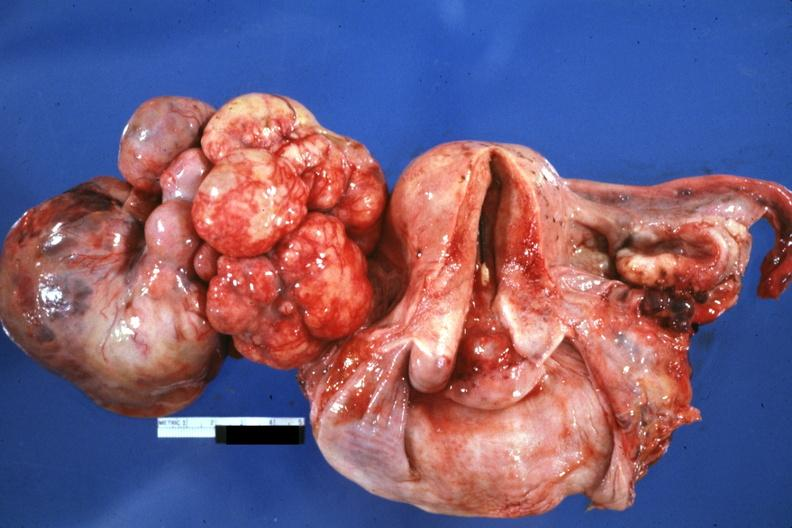does this image show large mass lobular tumor lung primary?
Answer the question using a single word or phrase. Yes 